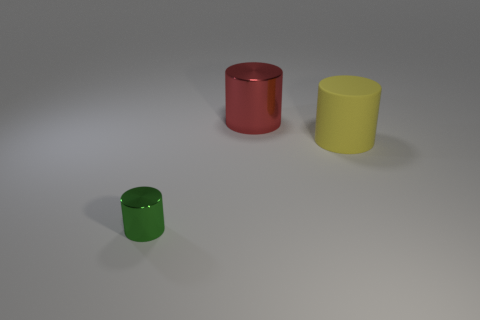Subtract all green metallic cylinders. How many cylinders are left? 2 Add 3 green metallic things. How many objects exist? 6 Subtract all yellow cylinders. How many cylinders are left? 2 Subtract 2 cylinders. How many cylinders are left? 1 Subtract all matte cylinders. Subtract all blocks. How many objects are left? 2 Add 2 matte cylinders. How many matte cylinders are left? 3 Add 1 big cyan shiny balls. How many big cyan shiny balls exist? 1 Subtract 0 brown blocks. How many objects are left? 3 Subtract all red cylinders. Subtract all yellow balls. How many cylinders are left? 2 